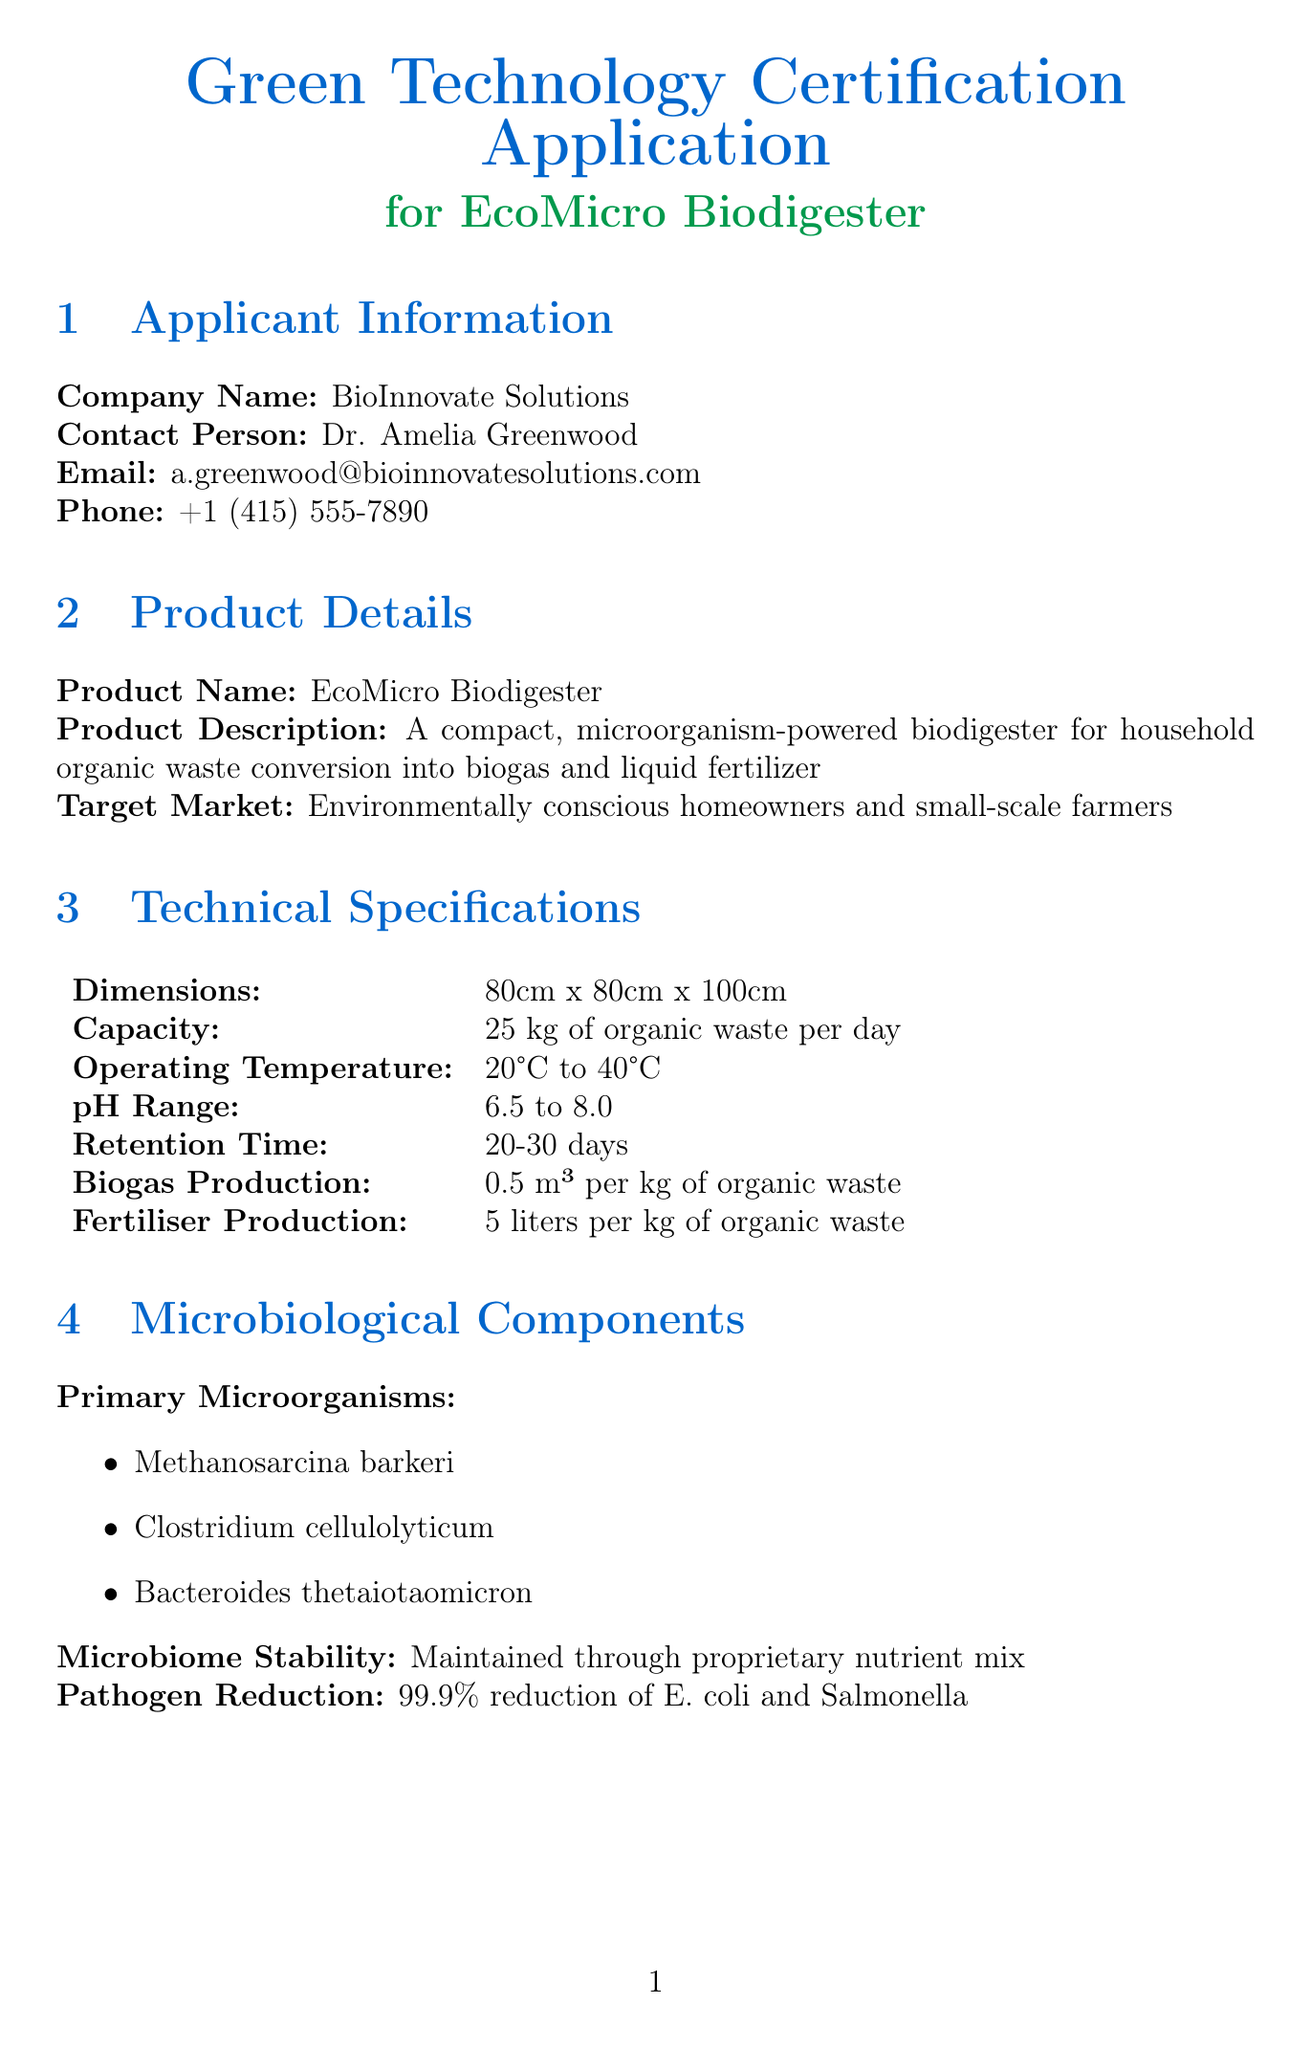What is the product name? The product name is listed in the document under Product Details.
Answer: EcoMicro Biodigester Who is the contact person for this application? The contact person is mentioned in the Applicant Information section.
Answer: Dr. Amelia Greenwood What is the daily capacity of the EcoMicro Biodigester? The capacity can be found in the Technical Specifications section.
Answer: 25 kg of organic waste per day What is the reduction in carbon footprint per kg of waste processed? The metric is specified in the Sustainability Metrics section.
Answer: 2.5 kg CO2e Which certifying body is associated with the ISO 14001 certification? The certifying body is indicated in the Certification Standards section.
Answer: SGS What is the pathogen reduction rate stated in the document? The pathogen reduction rate is mentioned under Microbiological Components.
Answer: 99.9% What percentage of recycled materials is used in construction? This information is detailed in the Life Cycle Assessment section.
Answer: 85% What is the date of the declaration of compliance? The date can be found at the end of the document in the Declaration of Compliance section.
Answer: 2023-05-15 How many liters of fertilizer are produced per kg of organic waste? This detail is present in the Technical Specifications section.
Answer: 5 liters per kg of organic waste 